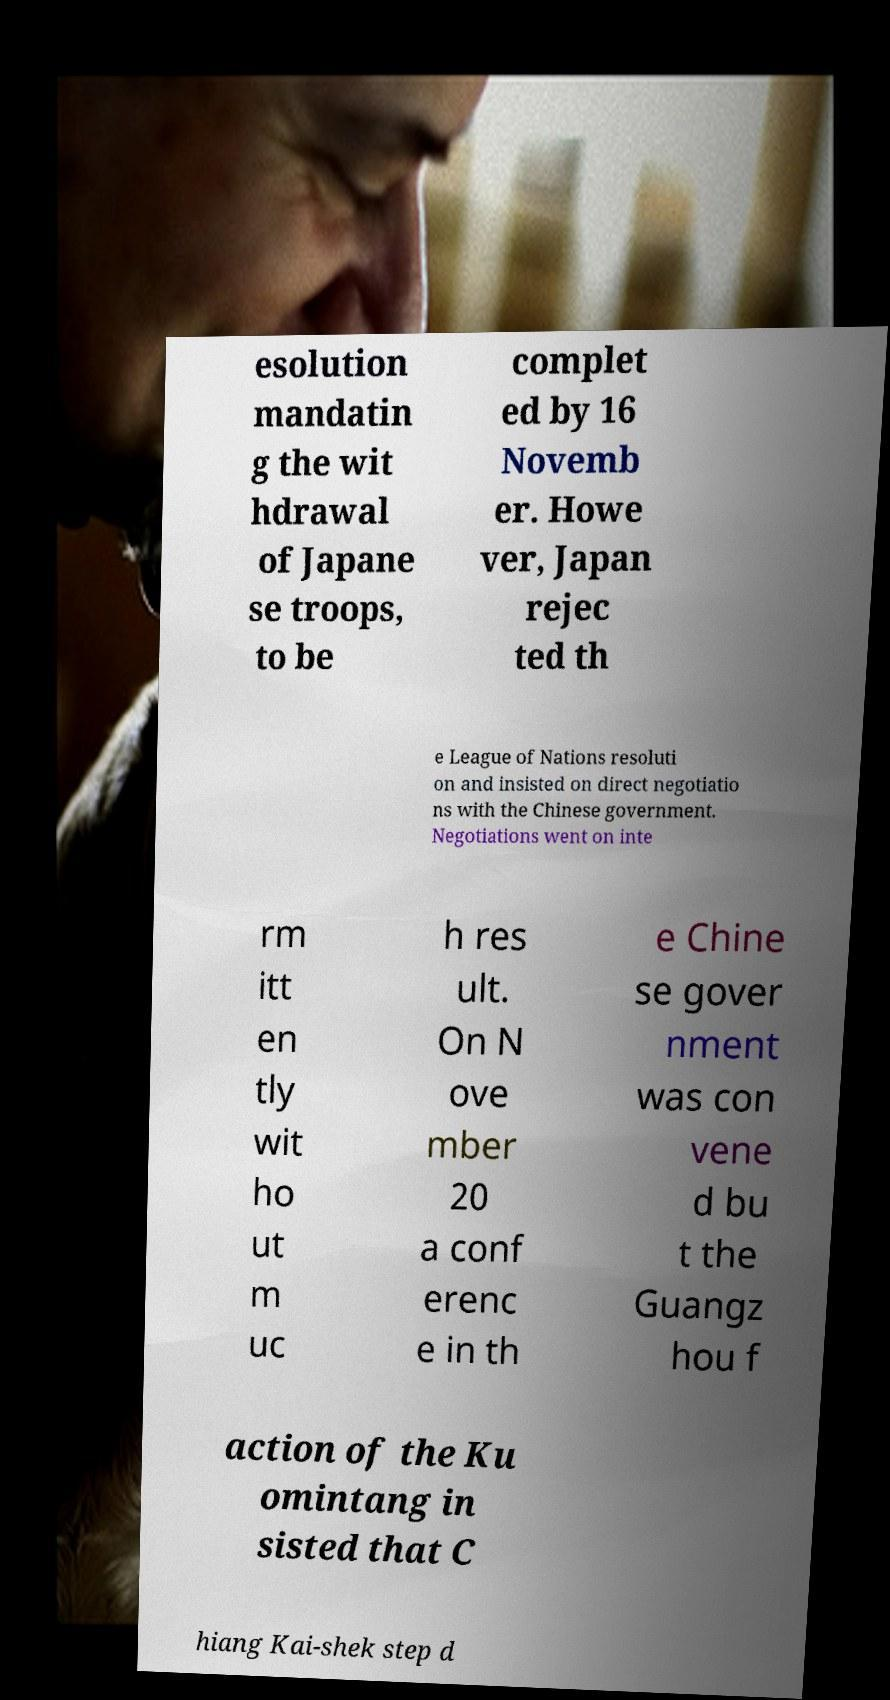Could you assist in decoding the text presented in this image and type it out clearly? esolution mandatin g the wit hdrawal of Japane se troops, to be complet ed by 16 Novemb er. Howe ver, Japan rejec ted th e League of Nations resoluti on and insisted on direct negotiatio ns with the Chinese government. Negotiations went on inte rm itt en tly wit ho ut m uc h res ult. On N ove mber 20 a conf erenc e in th e Chine se gover nment was con vene d bu t the Guangz hou f action of the Ku omintang in sisted that C hiang Kai-shek step d 